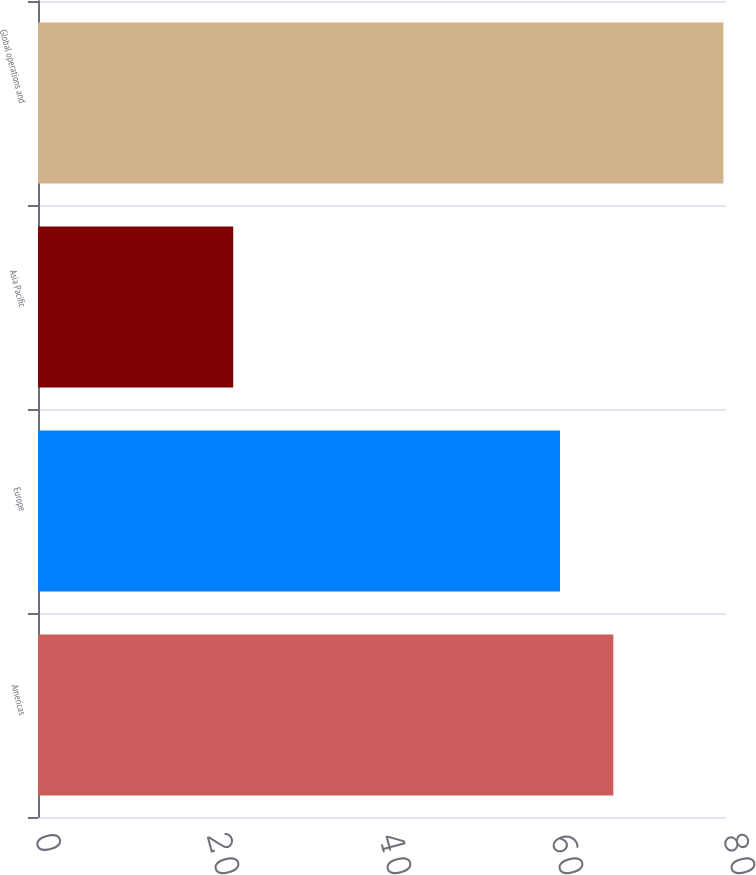Convert chart. <chart><loc_0><loc_0><loc_500><loc_500><bar_chart><fcel>Americas<fcel>Europe<fcel>Asia Pacific<fcel>Global operations and<nl><fcel>66.9<fcel>60.7<fcel>22.7<fcel>79.7<nl></chart> 